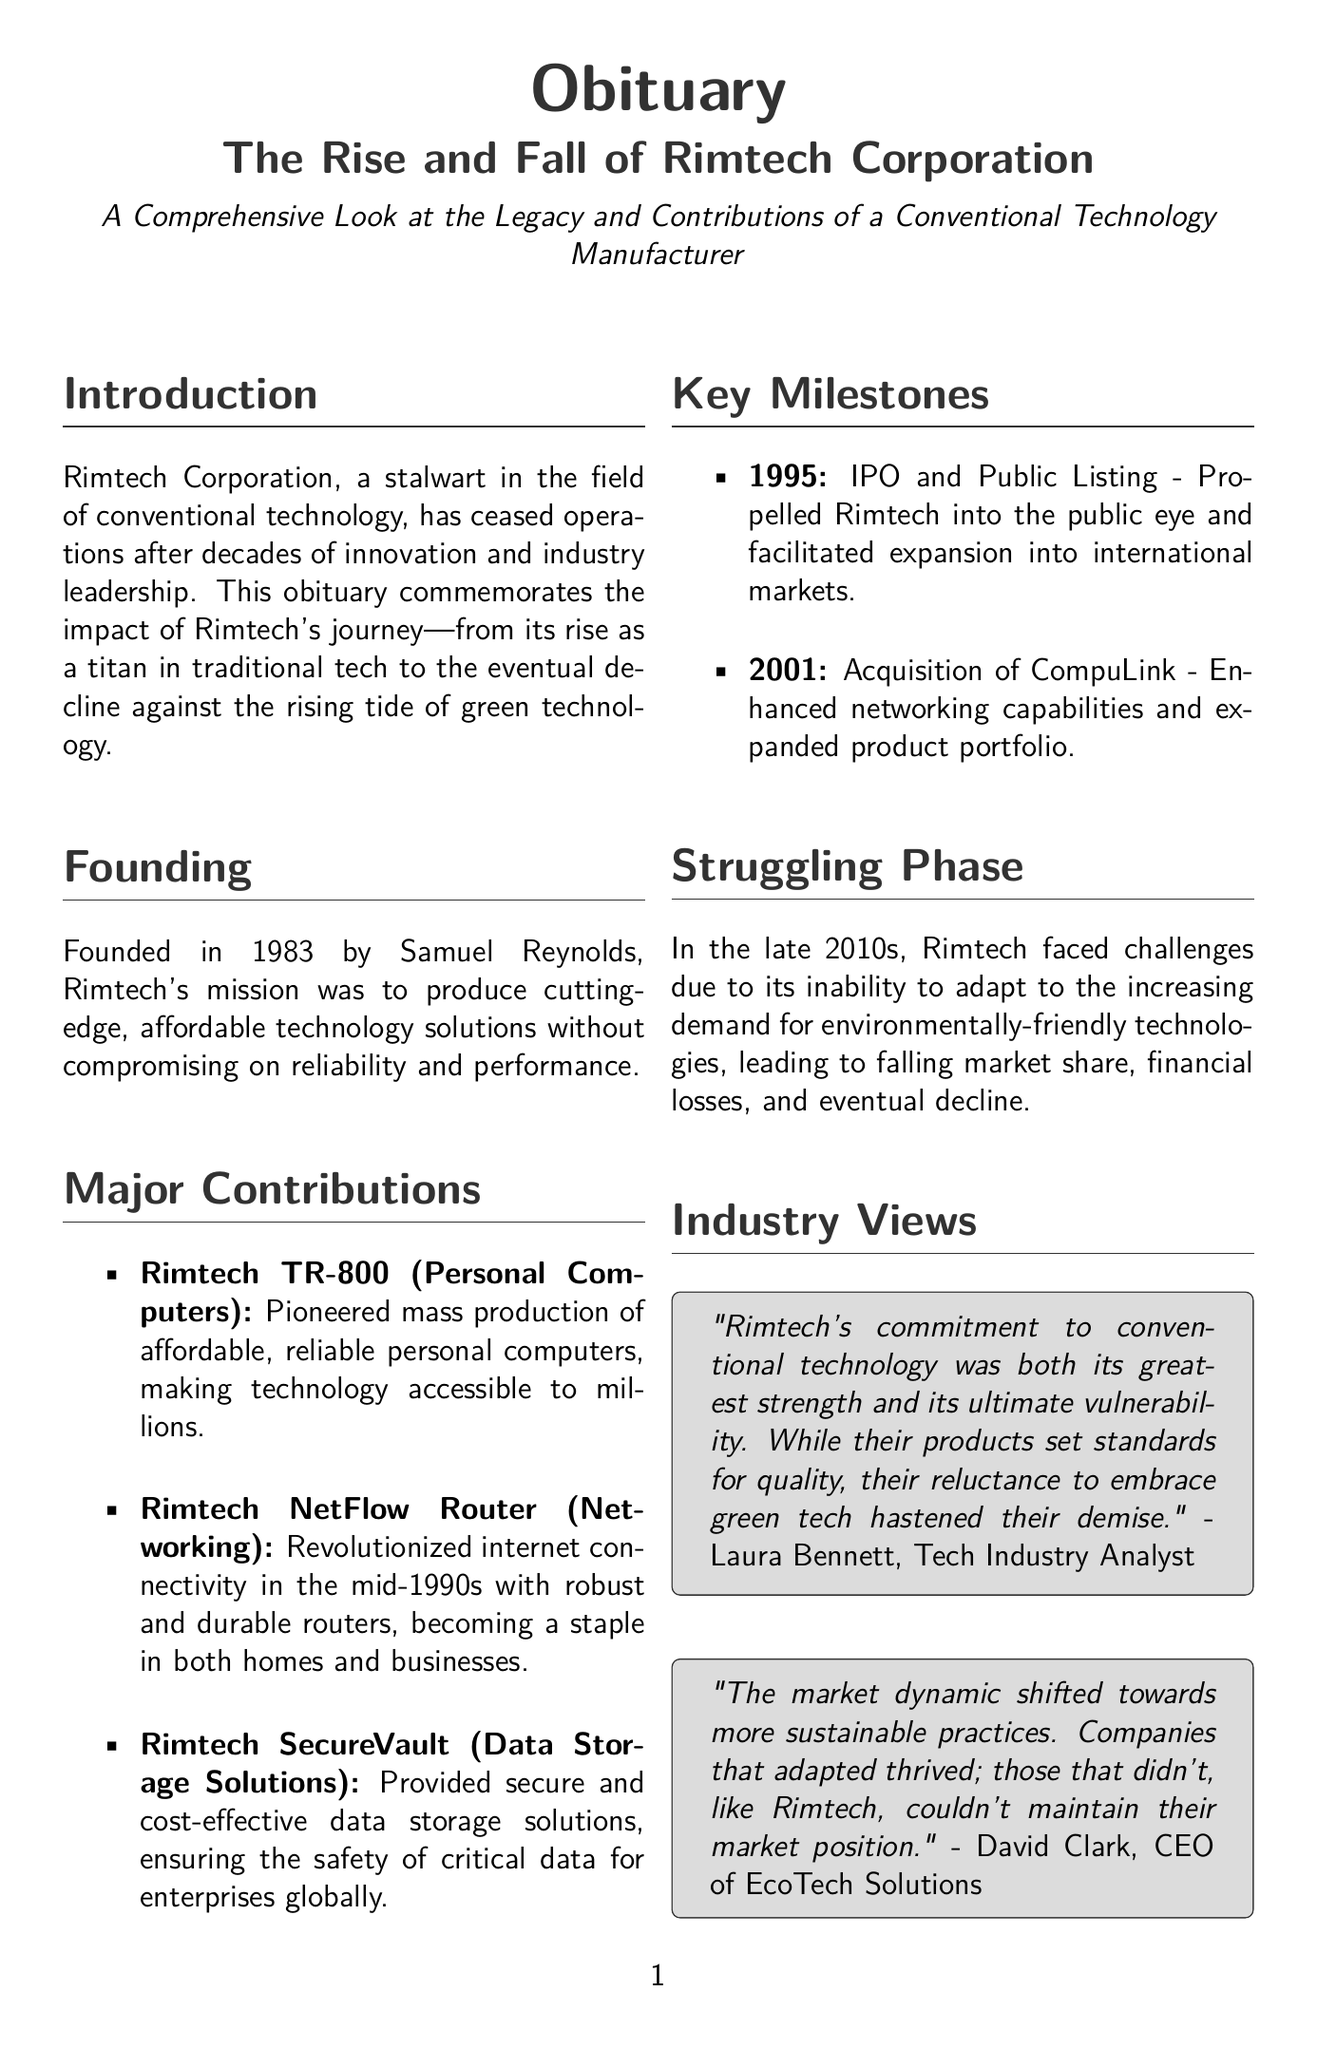What year was Rimtech Corporation founded? The document states that Rimtech Corporation was founded in 1983.
Answer: 1983 Who founded Rimtech Corporation? According to the document, Rimtech Corporation was founded by Samuel Reynolds.
Answer: Samuel Reynolds What was the major product launched in 1995? The document mentions that Rimtech had an IPO and public listing in 1995, which is a significant event.
Answer: IPO and Public Listing Which product revolutionized internet connectivity in the mid-1990s? The document specifies that the Rimtech NetFlow Router revolutionized internet connectivity in the mid-1990s.
Answer: Rimtech NetFlow Router What was one reason for Rimtech's decline in the late 2010s? The document notes that Rimtech faced challenges due to its inability to adapt to the increasing demand for environmentally-friendly technologies.
Answer: Inability to adapt to green technology Who stated that Rimtech's commitment to conventional technology was a vulnerability? The document quotes Laura Bennett, a tech industry analyst, regarding this statement about Rimtech.
Answer: Laura Bennett What does the final statement suggest about Rimtech Corporation? The final statement in the document indicates that Rimtech Corporation will be remembered as a pioneer in technological progress.
Answer: Pioneer in technological progress What year was the acquisition of CompuLink? The document mentions that the acquisition of CompuLink took place in 2001.
Answer: 2001 